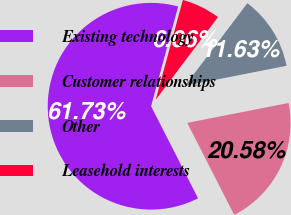Convert chart. <chart><loc_0><loc_0><loc_500><loc_500><pie_chart><fcel>Existing technology<fcel>Customer relationships<fcel>Other<fcel>Leasehold interests<nl><fcel>61.73%<fcel>20.58%<fcel>11.63%<fcel>6.06%<nl></chart> 